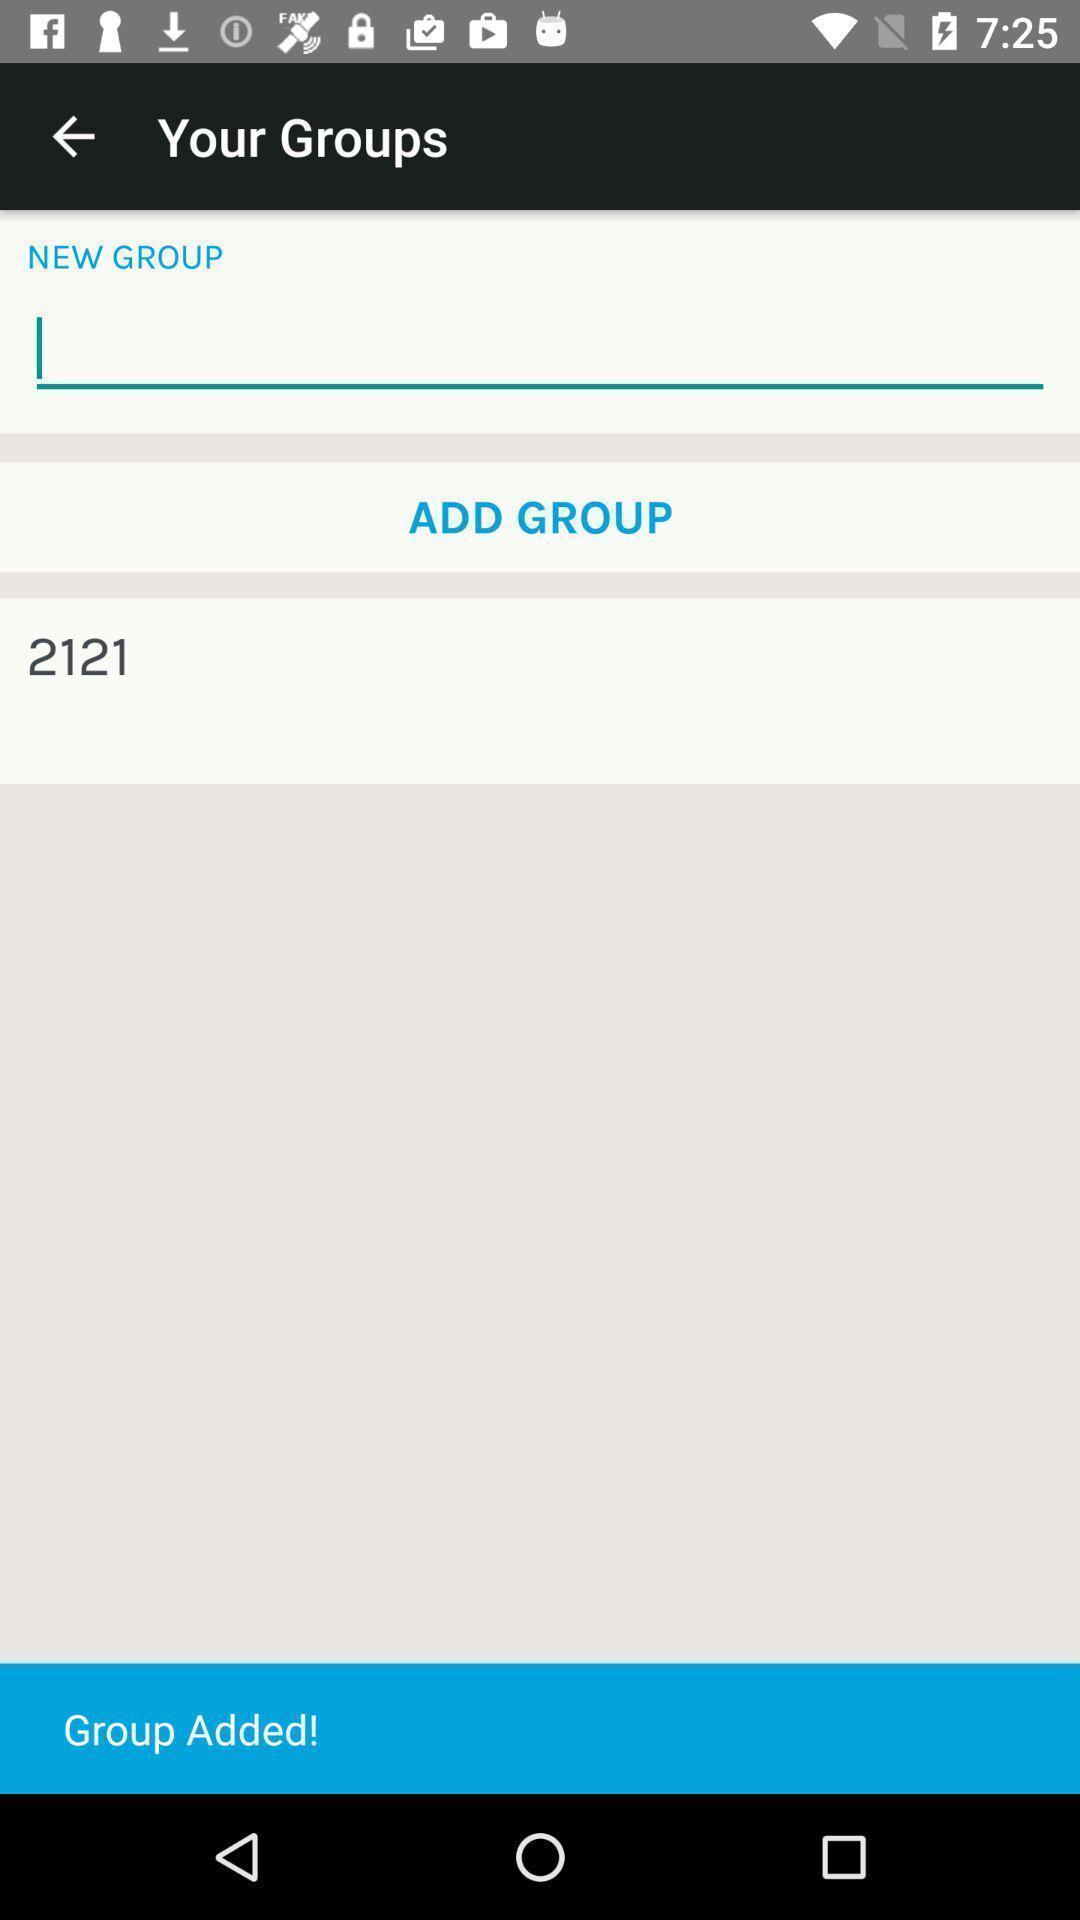Summarize the information in this screenshot. Screen shows group details. 